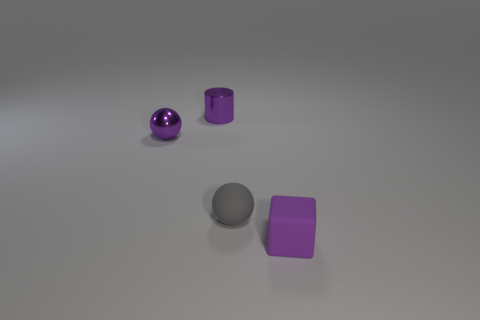What material is the thing that is to the right of the purple sphere and left of the gray thing?
Make the answer very short. Metal. How many other metallic things have the same shape as the tiny gray thing?
Offer a terse response. 1. The small thing in front of the matte thing that is left of the small purple rubber cube is what color?
Offer a very short reply. Purple. Are there an equal number of rubber balls to the right of the gray sphere and large red metal objects?
Ensure brevity in your answer.  Yes. Are there any matte blocks of the same size as the purple cylinder?
Give a very brief answer. Yes. There is a shiny cylinder; does it have the same size as the ball in front of the small purple shiny ball?
Offer a very short reply. Yes. Are there an equal number of tiny gray rubber things to the right of the tiny purple ball and purple cubes left of the small rubber sphere?
Give a very brief answer. No. What shape is the rubber object that is the same color as the tiny metallic sphere?
Offer a terse response. Cube. There is a purple thing that is in front of the purple metal ball; what is its material?
Make the answer very short. Rubber. Do the gray ball and the purple cube have the same size?
Give a very brief answer. Yes. 